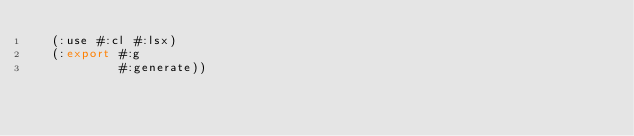<code> <loc_0><loc_0><loc_500><loc_500><_Lisp_>  (:use #:cl #:lsx)
  (:export #:g
           #:generate))
</code> 